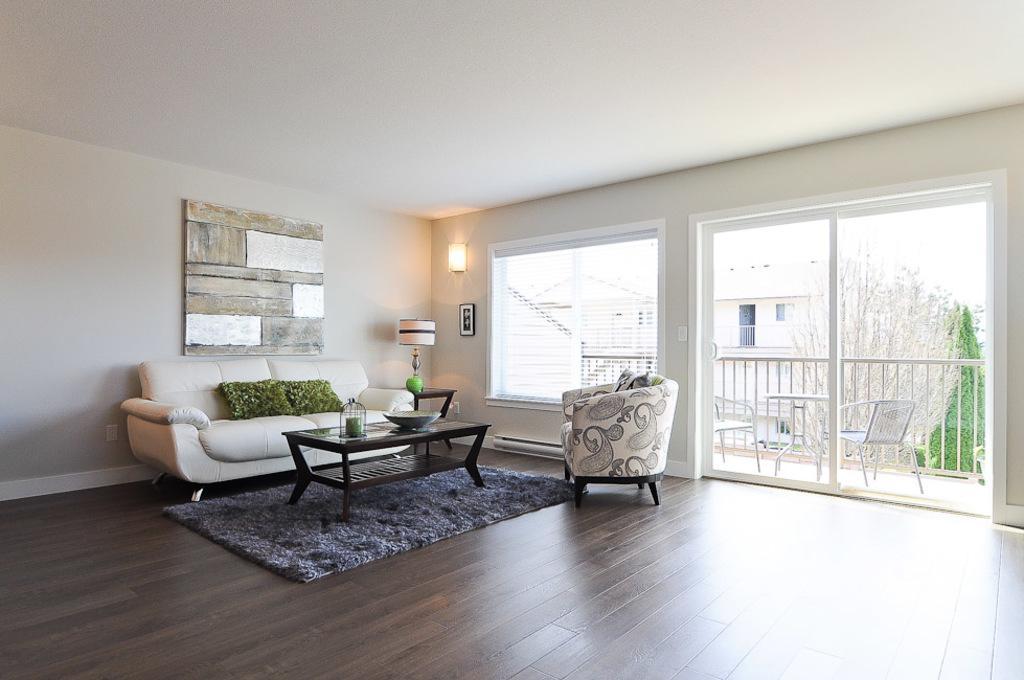How would you summarize this image in a sentence or two? This is an inside view. In the middle of the room there is a white color couch. In front of this there is a table. On which few objects are placed. At the back of this cough there is a wall on which a board is attached. On the right side of the image there is a window through that we can see the outside view. 